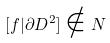<formula> <loc_0><loc_0><loc_500><loc_500>[ f | \partial D ^ { 2 } ] \notin N</formula> 